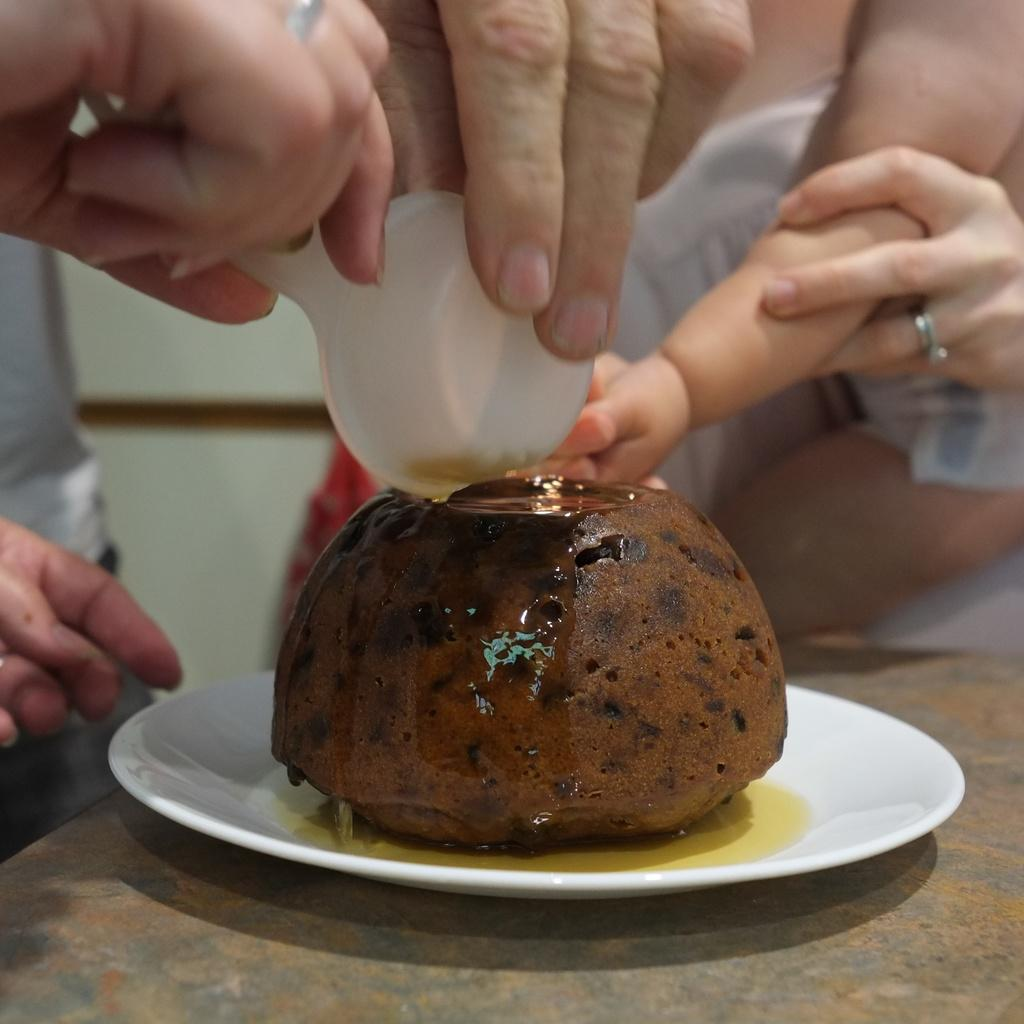What is on the plate that is visible in the image? There is food on a plate in the image. Where is the plate located in the image? The plate is on a table in the image. What are the persons in the image doing with the spoons? The persons are holding spoons and putting them on the food in the image. Can you describe the interaction between the persons in the image? There is a person holding the hand of a kid in the image. What type of polish is being applied to the food in the image? There is no polish present in the image, and the food is not being polished. 